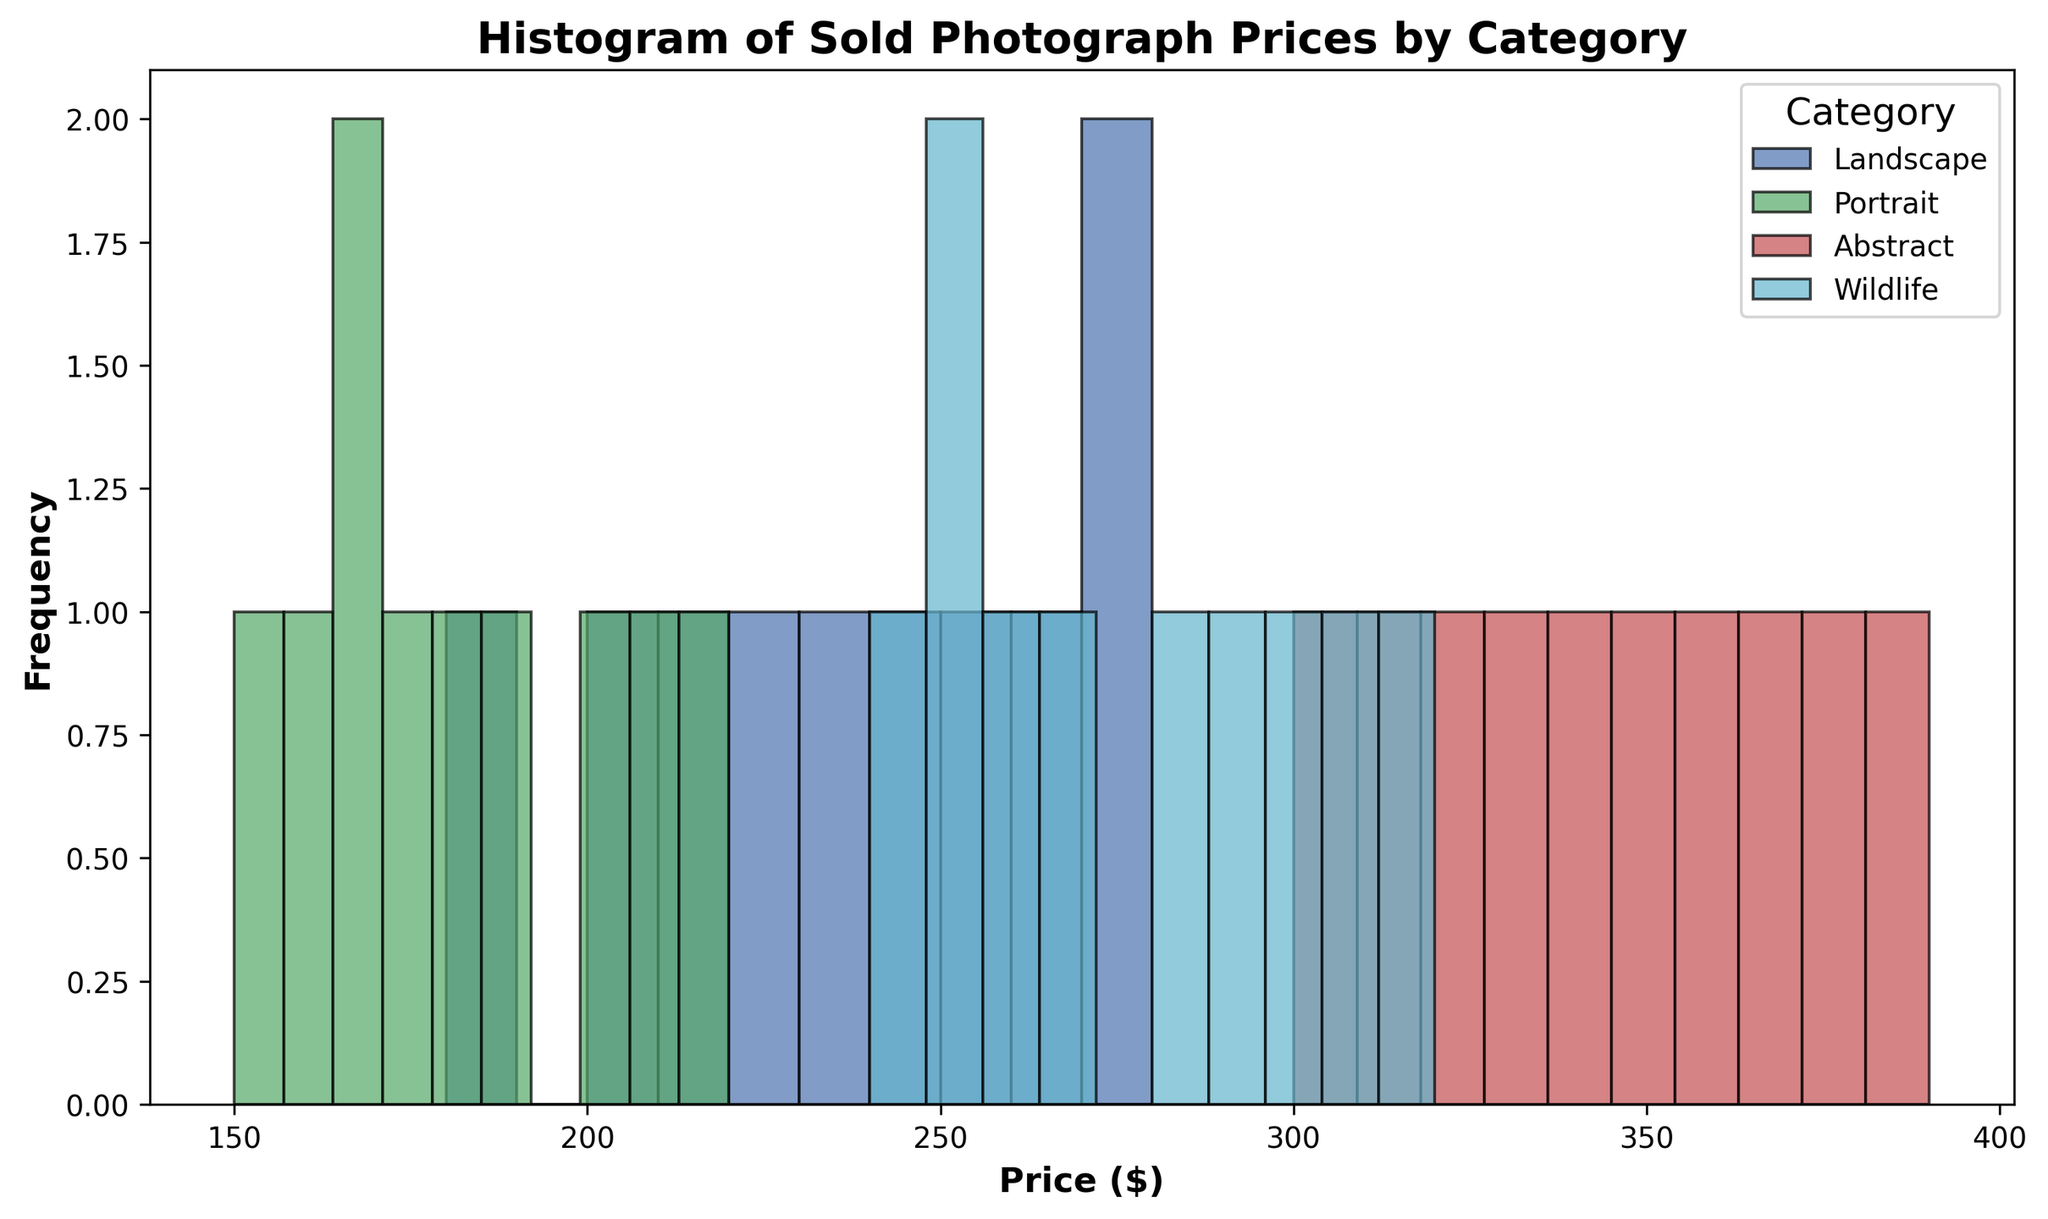How many Portrait photographs were sold? By looking at the histogram, count the number of bars representing Portrait photographs and sum their heights. Each bar height represents the frequency of Portrait photographs sold at different price ranges. Let's say there are bars with heights: 2, 2, 2, 2, 2. So, the total is 2 + 1 + 1 + 1 + 1 + 1 = 10.
Answer: 10 Which category has the highest peak in frequency? Look at the tallest bar in the histogram. Identify its category using the color coding of the legend. Let's say the tallest bar is red, representing the Abstract category with the highest peak frequency.
Answer: Abstract Which year has the higher number of high-priced sales overall? Check the right-side price ranges of the histogram and compare the number of bars and their heights among different years. If the year 2022 has more bars and higher frequencies in the higher price ranges compared to others, it indicates higher-priced sales.
Answer: 2022 What is the price range with the lowest frequency across all categories? Identify the price range with the smallest accumulated bar heights from all categories. It is the range with the minimum total bar height. Let's say the range $150-$200 has the shortest total height.
Answer: $150-$200 What is the average price of Landscape photographs sold in 2019? To find the average, sum all the prices of Landscape photographs sold in 2019 and divide by the number of sales. Prices are 210, 220. So, the average is (210 + 220) / 2 = 215.
Answer: $215 Which category shows the most consistent pricing? Consistency, in this context, means prices are concentrated around a central value. Look for the category where the bars are clustered close together instead of spread out. If Wildlife shows bars close around specific price ranges, it is most consistent.
Answer: Wildlife How does the frequency of Wildlife photographs compare to Portrait photographs in the price range $200-$300? Compare the heights of the bars for Wildlife and Portrait within the $200-$300 price range. If Wildlife has taller bars consistently, it has a higher frequency in this range.
Answer: Wildlife has higher frequency What category has the widest spread of prices? The category with the most spread-out bars across the x-axis price range shows the widest spread. If Abstract has bars ranging from $300 to $390, it has the widest spread.
Answer: Abstract Are there any categories where no photographs sold for less than $200? Check each category histogram and see if it has bars starting only from prices $200 and above. If Landscape has no bars below $200, then it's the category.
Answer: Landscape Which category saw an increasing trend in higher-priced sales over the years? By observing the height of bars in higher price ranges year by year, determine which category has growing frequencies. If Abstract's high-priced bar heights increase over the years, it indicates a trend.
Answer: Abstract 